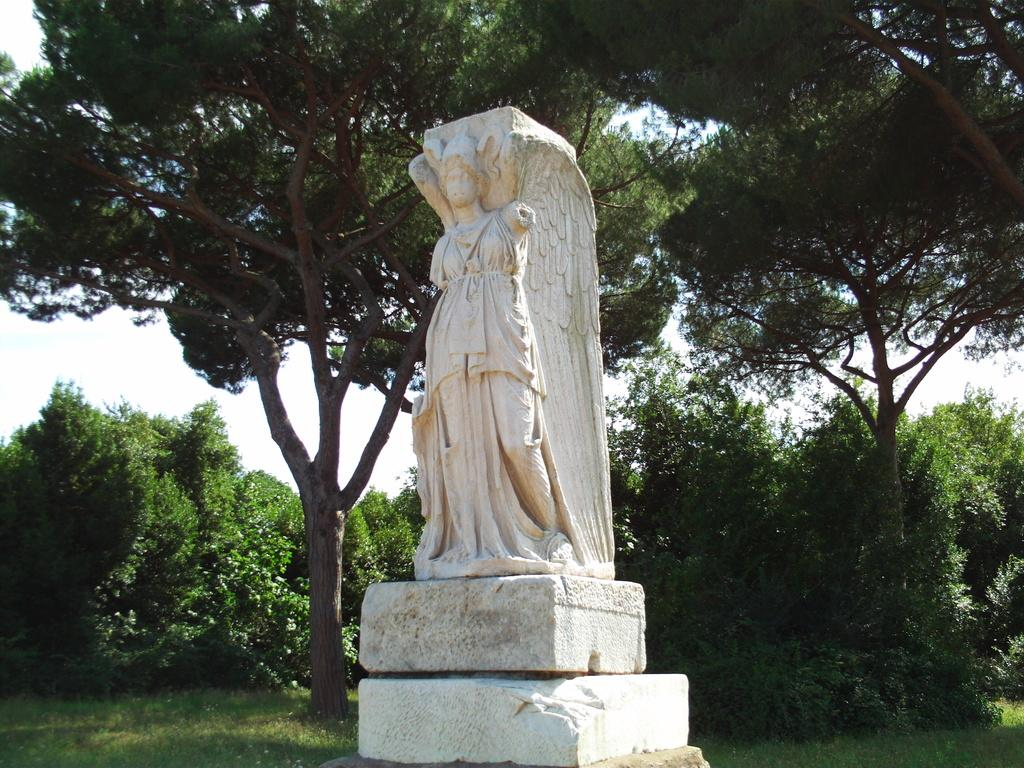What is the main subject of the image? There is a statue of a person in the image. Where is the statue located? The statue is on a platform. What can be seen in the background of the image? There are trees and grass on the ground in the background. What is visible in the sky? There are: There are clouds in the sky. What is the income of the person depicted in the statue? The income of the person depicted in the statue cannot be determined from the image, as it is a statue and not a real person. 